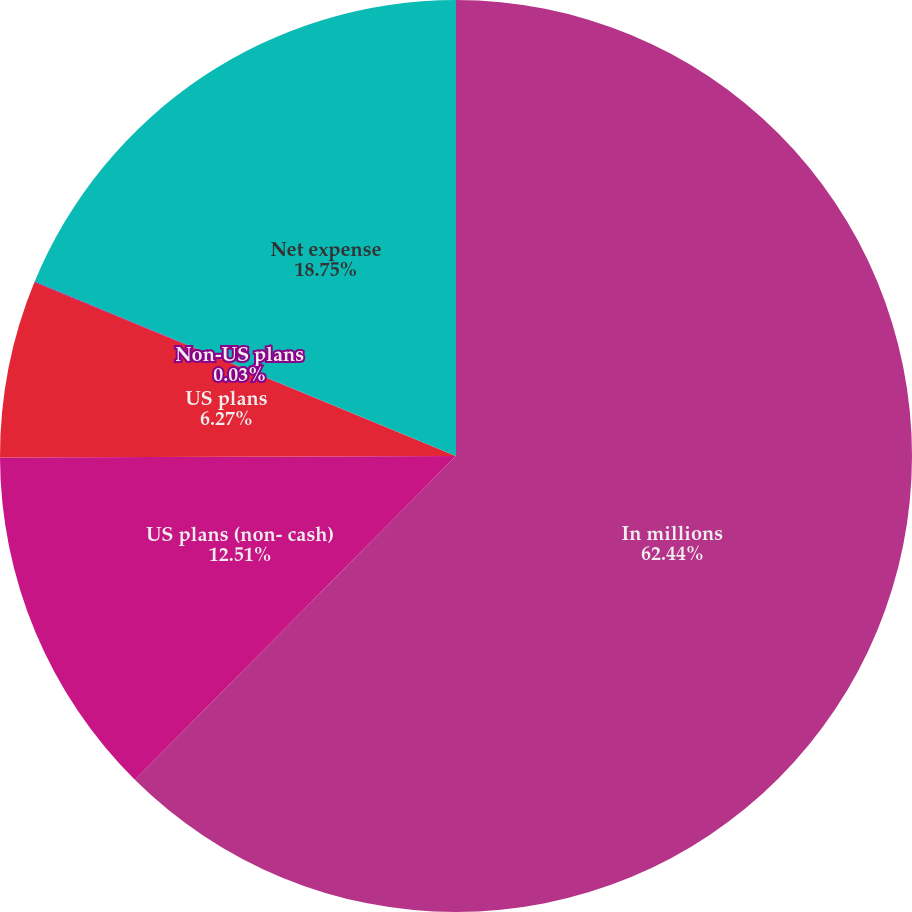Convert chart. <chart><loc_0><loc_0><loc_500><loc_500><pie_chart><fcel>In millions<fcel>US plans (non- cash)<fcel>US plans<fcel>Non-US plans<fcel>Net expense<nl><fcel>62.43%<fcel>12.51%<fcel>6.27%<fcel>0.03%<fcel>18.75%<nl></chart> 